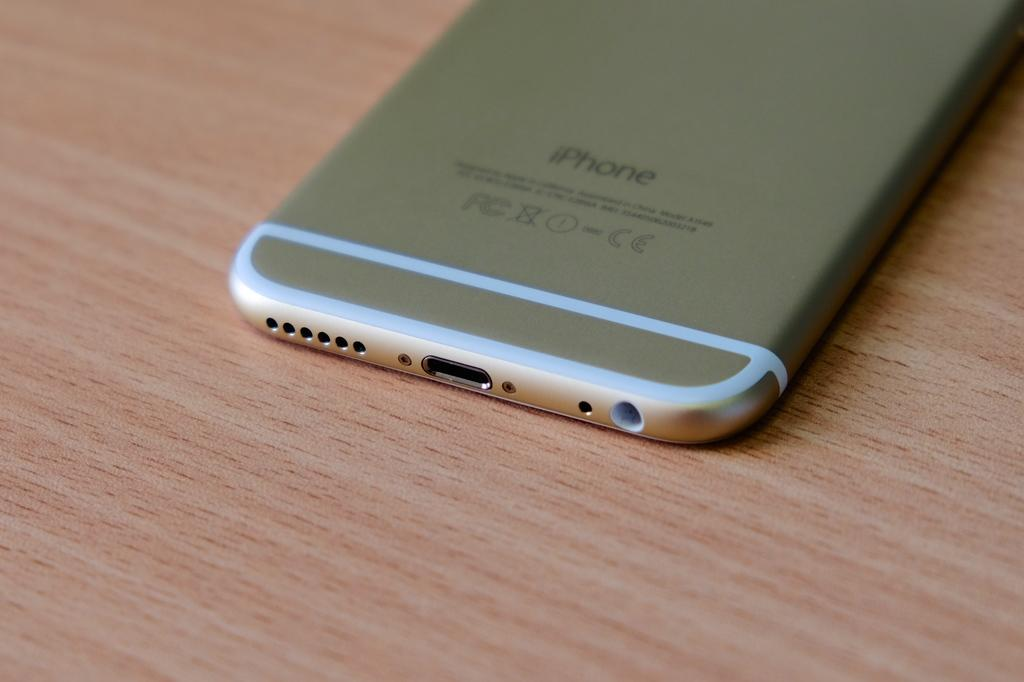<image>
Share a concise interpretation of the image provided. An iPhone is on a table with the screen facing down. 